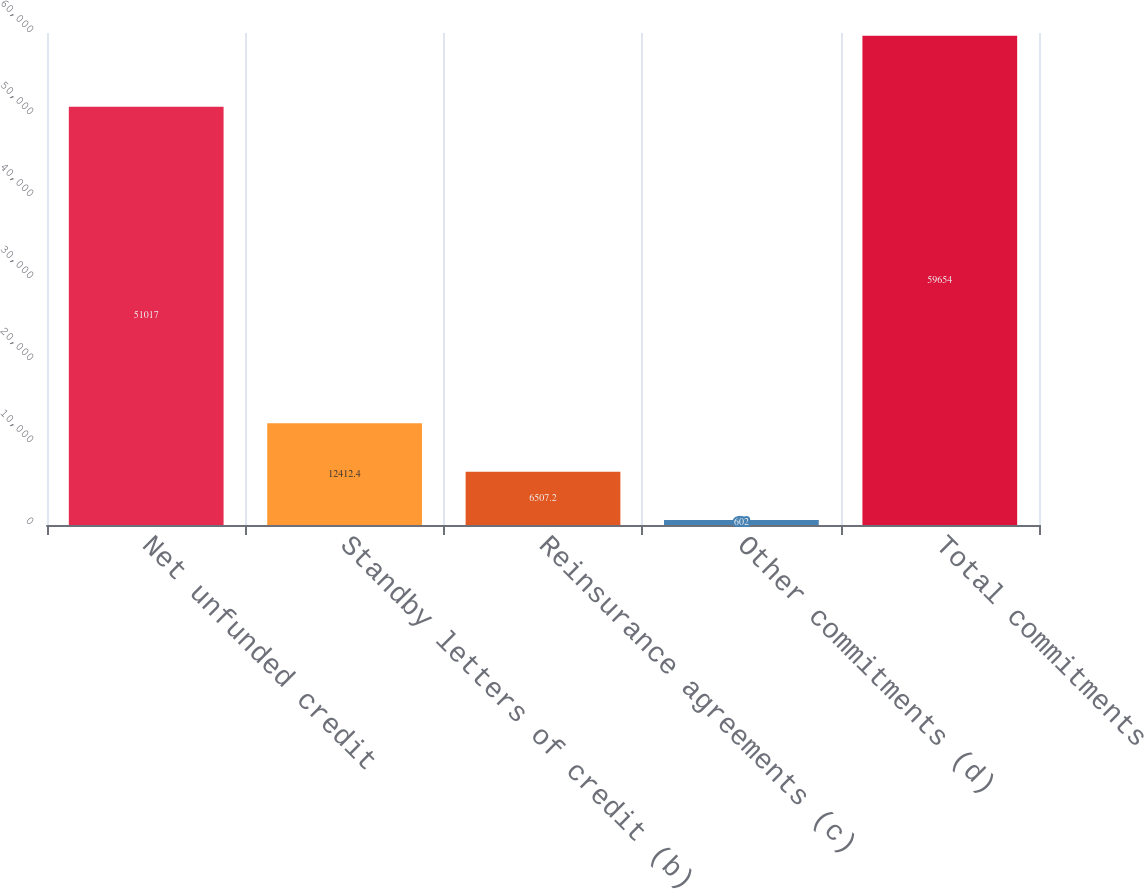Convert chart to OTSL. <chart><loc_0><loc_0><loc_500><loc_500><bar_chart><fcel>Net unfunded credit<fcel>Standby letters of credit (b)<fcel>Reinsurance agreements (c)<fcel>Other commitments (d)<fcel>Total commitments<nl><fcel>51017<fcel>12412.4<fcel>6507.2<fcel>602<fcel>59654<nl></chart> 